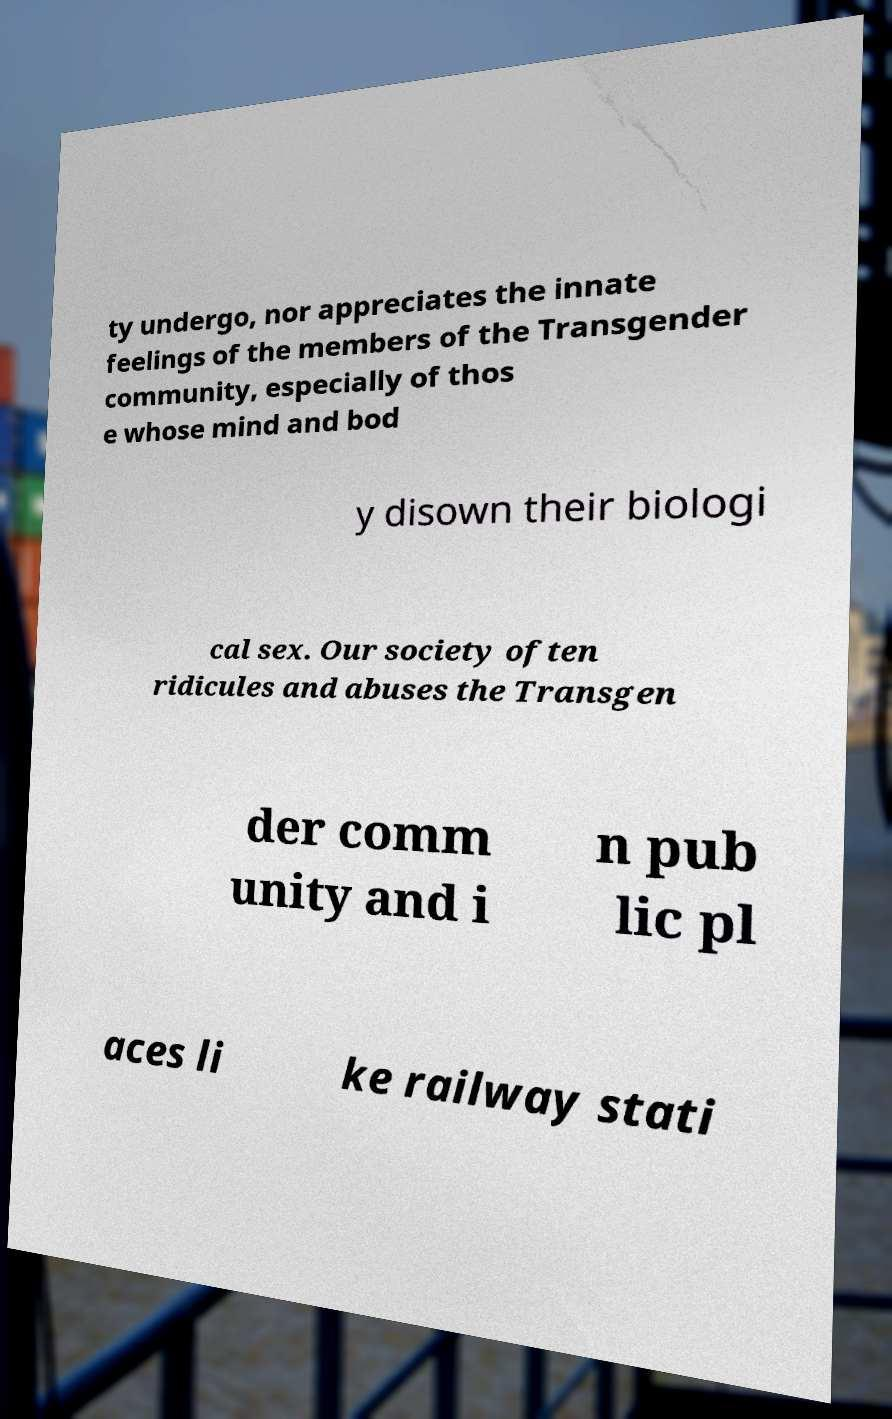Can you accurately transcribe the text from the provided image for me? ty undergo, nor appreciates the innate feelings of the members of the Transgender community, especially of thos e whose mind and bod y disown their biologi cal sex. Our society often ridicules and abuses the Transgen der comm unity and i n pub lic pl aces li ke railway stati 